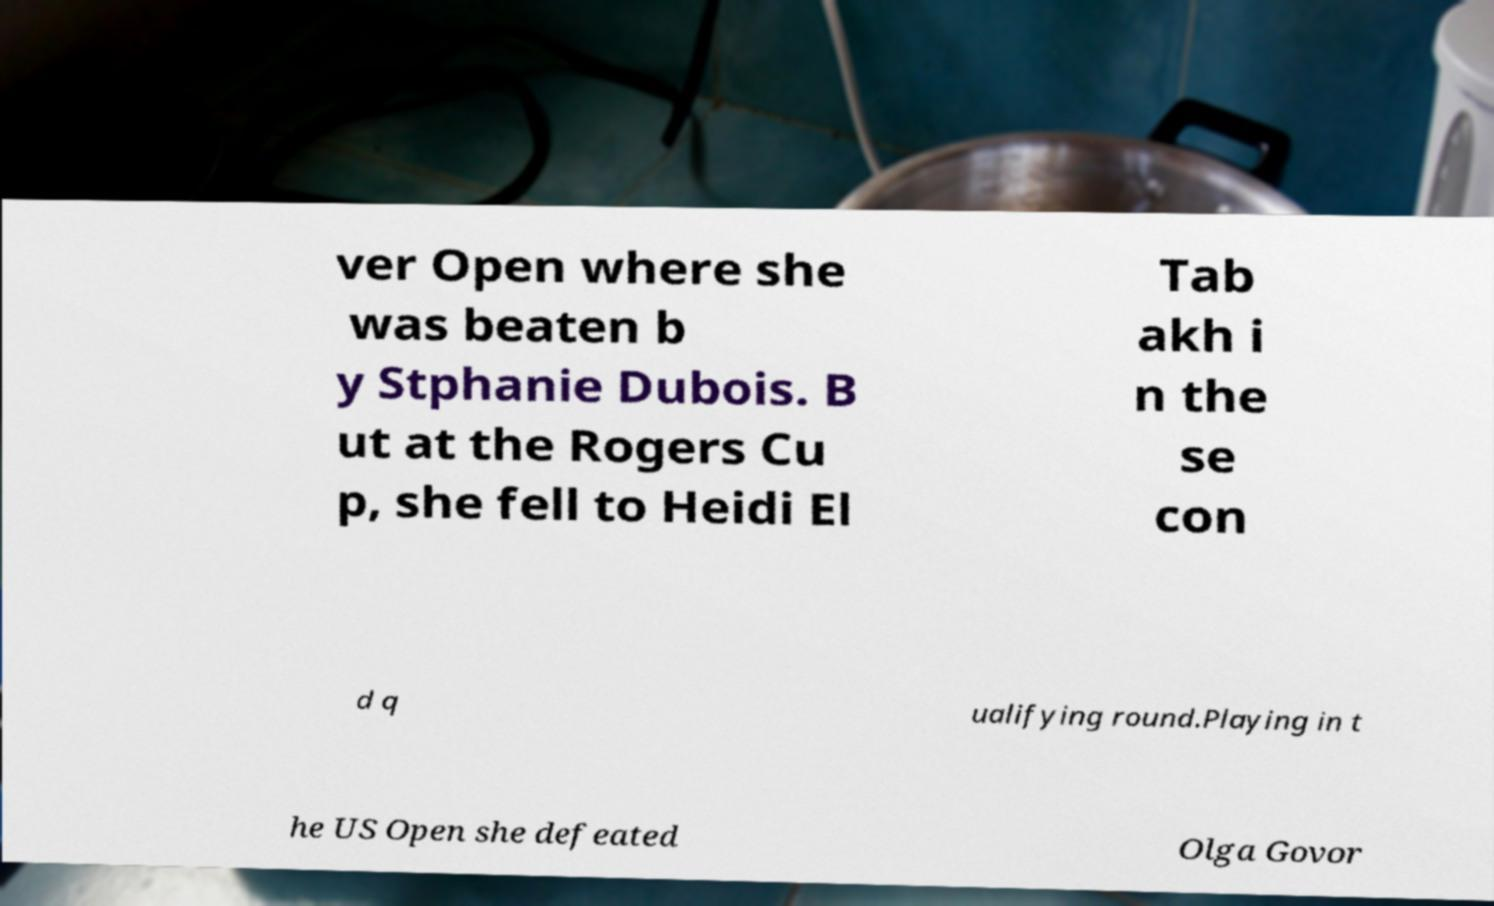Can you read and provide the text displayed in the image?This photo seems to have some interesting text. Can you extract and type it out for me? ver Open where she was beaten b y Stphanie Dubois. B ut at the Rogers Cu p, she fell to Heidi El Tab akh i n the se con d q ualifying round.Playing in t he US Open she defeated Olga Govor 